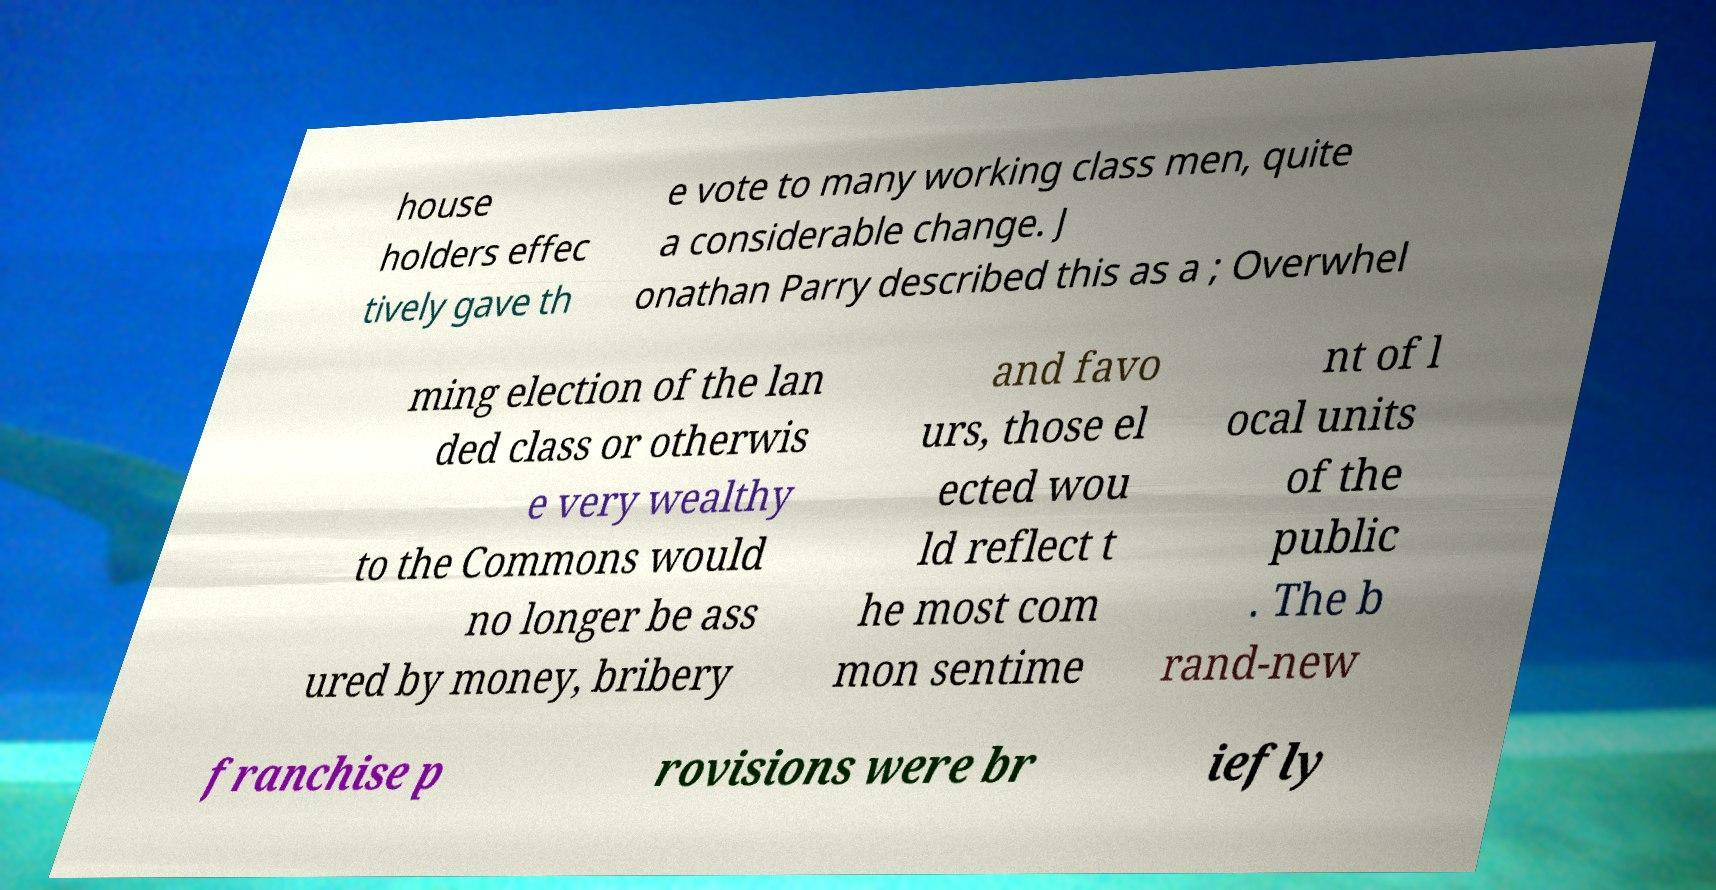For documentation purposes, I need the text within this image transcribed. Could you provide that? house holders effec tively gave th e vote to many working class men, quite a considerable change. J onathan Parry described this as a ; Overwhel ming election of the lan ded class or otherwis e very wealthy to the Commons would no longer be ass ured by money, bribery and favo urs, those el ected wou ld reflect t he most com mon sentime nt of l ocal units of the public . The b rand-new franchise p rovisions were br iefly 